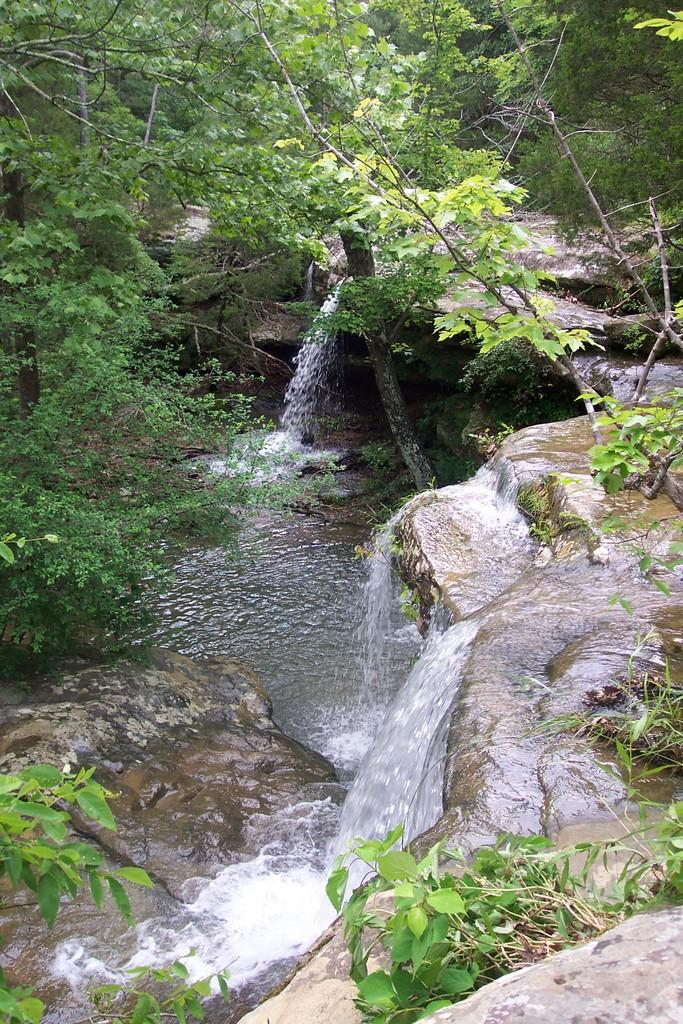What natural feature is the main subject of the image? There is a waterfall in the image. What type of vegetation can be seen in the image? There are trees in the image. What type of letter is being delivered at the waterfall in the image? There is no letter or any indication of a delivery in the image; it only features a waterfall and trees. 